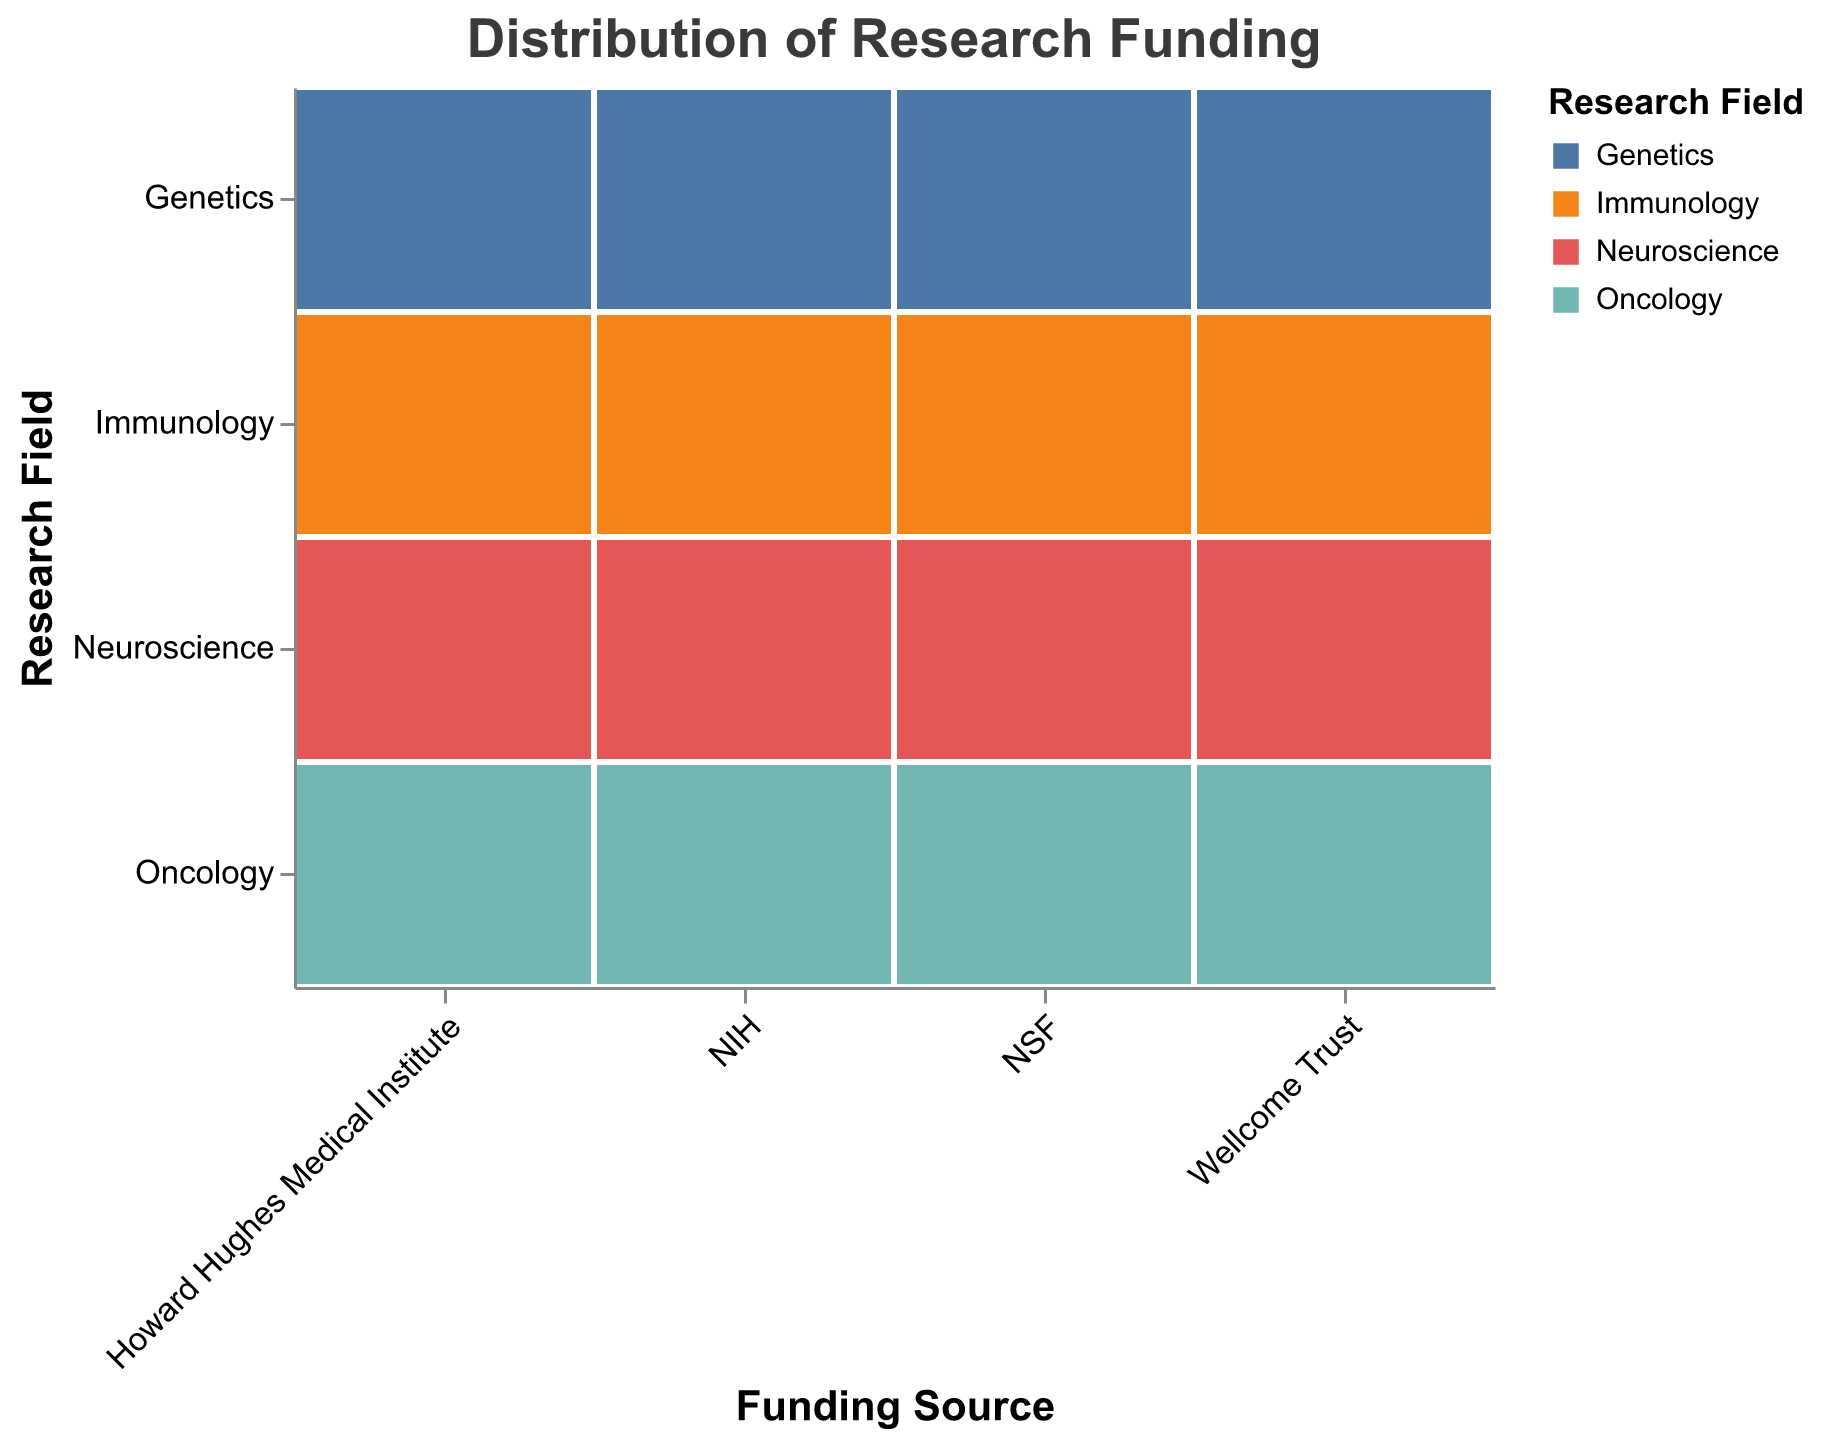What is the total funding amount in millions for Neuroscience from all sources? To find the total funding for Neuroscience, add the contributions from each funding source: NIH (450), NSF (120), Wellcome Trust (90), and Howard Hughes Medical Institute (180). The sum is 450 + 120 + 90 + 180.
Answer: 840 Which funding source contributes the most to Oncology research? Look at the funding amounts for Oncology from each source: NIH (680), NSF (80), Wellcome Trust (130), and Howard Hughes Medical Institute (220). The highest value is 680, which comes from NIH.
Answer: NIH How much more does NIH fund Immunology compared to NSF? NIH funds Immunology with 320 million, while NSF funds it with 60 million. Subtract the NSF amount from the NIH amount: 320 - 60.
Answer: 260 What research field receives the least funding from the Wellcome Trust? Compare the funding amounts for Neuroscience (90), Oncology (130), Immunology (70), and Genetics (85) from the Wellcome Trust. The smallest value is 70 for Immunology.
Answer: Immunology Which research field receives the most funding from all sources combined? Calculate the total funding for each field by adding the contributions from all sources:
Neuroscience: 450 + 120 + 90 + 180 = 840,
Oncology: 680 + 80 + 130 + 220 = 1110,
Immunology: 320 + 60 + 70 + 95 = 545,
Genetics: 290 + 110 + 85 + 140 = 625.
The highest total is for Oncology.
Answer: Oncology Is the amount of NIH funding for Genetics greater than the total NSF funding across all fields? NIH funding for Genetics is 290 million. The total NSF funding across all fields is:
Neuroscience (120) + Oncology (80) + Immunology (60) + Genetics (110) = 370 million. 290 is not greater than 370.
Answer: No Which funding source provides the lowest total funding across all research fields? Calculate the total funding by adding the amounts for each field within each funding source:
NIH: 450 + 680 + 320 + 290 = 1740,
NSF: 120 + 80 + 60 + 110 = 370,
Wellcome Trust: 90 + 130 + 70 + 85 = 375,
Howard Hughes Medical Institute: 180 + 220 + 95 + 140 = 635.
The lowest total funding is from NSF.
Answer: NSF How does the Howard Hughes Medical Institute's funding for Neuroscience compare to its funding for Immunology? The funding for Neuroscience from the Howard Hughes Medical Institute is 180 million, while for Immunology, it is 95 million. 180 is greater than 95.
Answer: Greater What's the difference in Oncology funding between Wellcome Trust and Howard Hughes Medical Institute? The Wellcome Trust funds Oncology with 130 million, and Howard Hughes Medical Institute funds it with 220 million. Subtract 130 from 220.
Answer: 90 